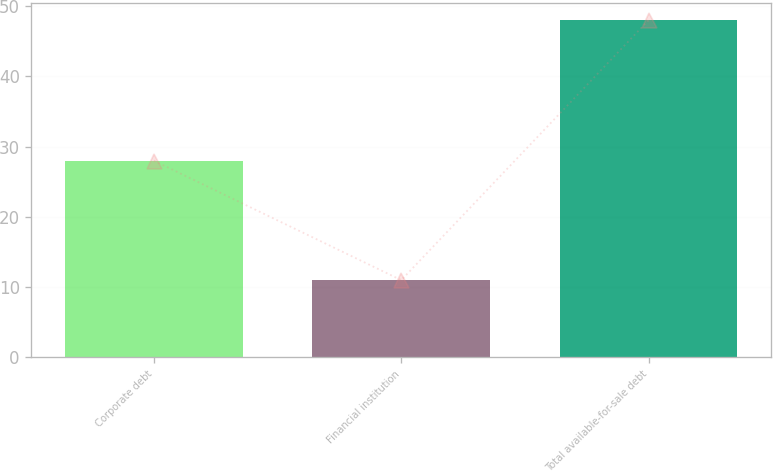Convert chart. <chart><loc_0><loc_0><loc_500><loc_500><bar_chart><fcel>Corporate debt<fcel>Financial institution<fcel>Total available-for-sale debt<nl><fcel>28<fcel>11<fcel>48<nl></chart> 